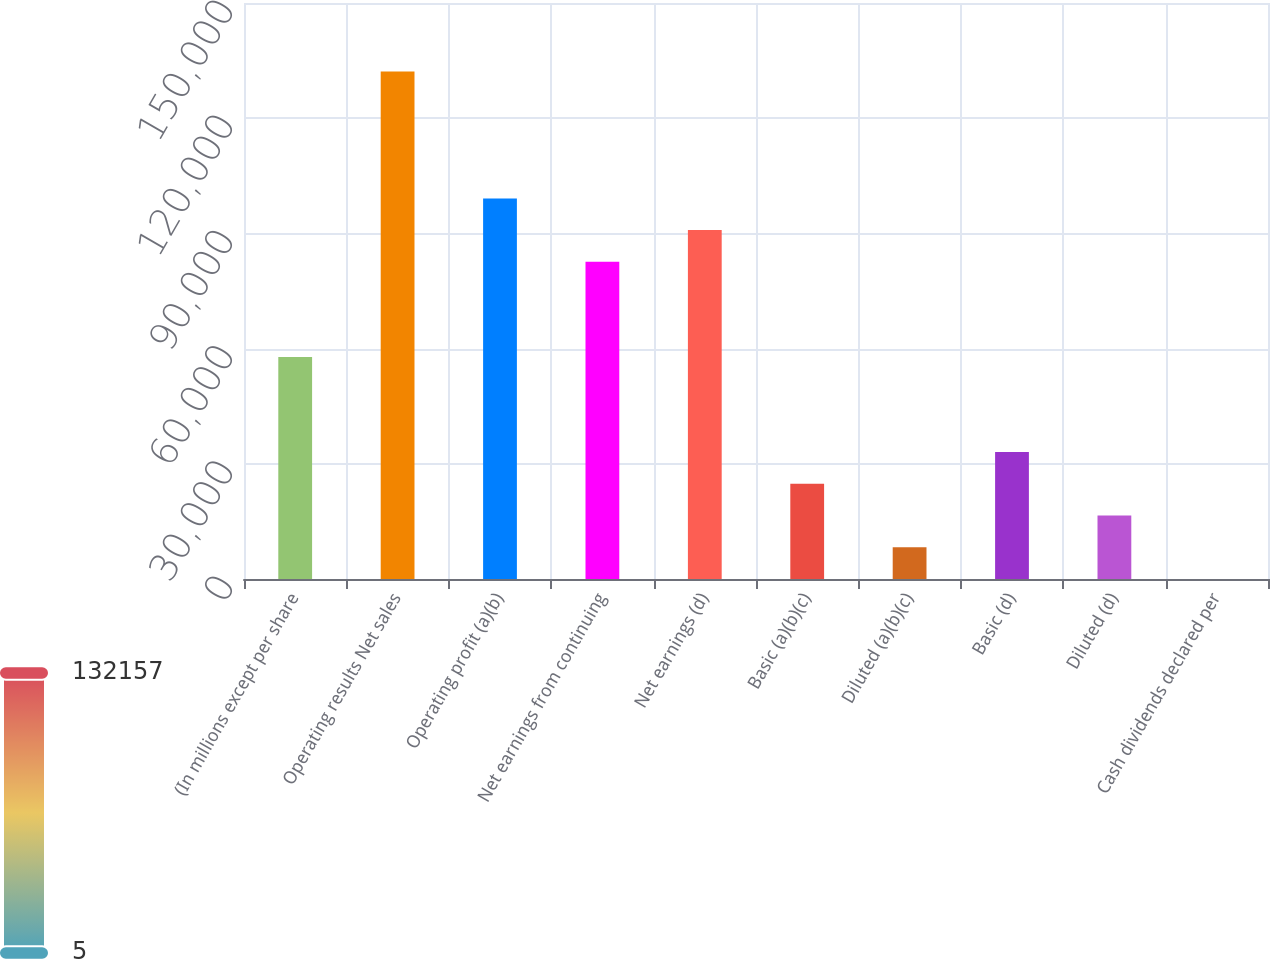<chart> <loc_0><loc_0><loc_500><loc_500><bar_chart><fcel>(In millions except per share<fcel>Operating results Net sales<fcel>Operating profit (a)(b)<fcel>Net earnings from continuing<fcel>Net earnings (d)<fcel>Basic (a)(b)(c)<fcel>Diluted (a)(b)(c)<fcel>Basic (d)<fcel>Diluted (d)<fcel>Cash dividends declared per<nl><fcel>57821.4<fcel>132157<fcel>99119<fcel>82600<fcel>90859.5<fcel>24783.3<fcel>8264.3<fcel>33042.9<fcel>16523.8<fcel>4.78<nl></chart> 